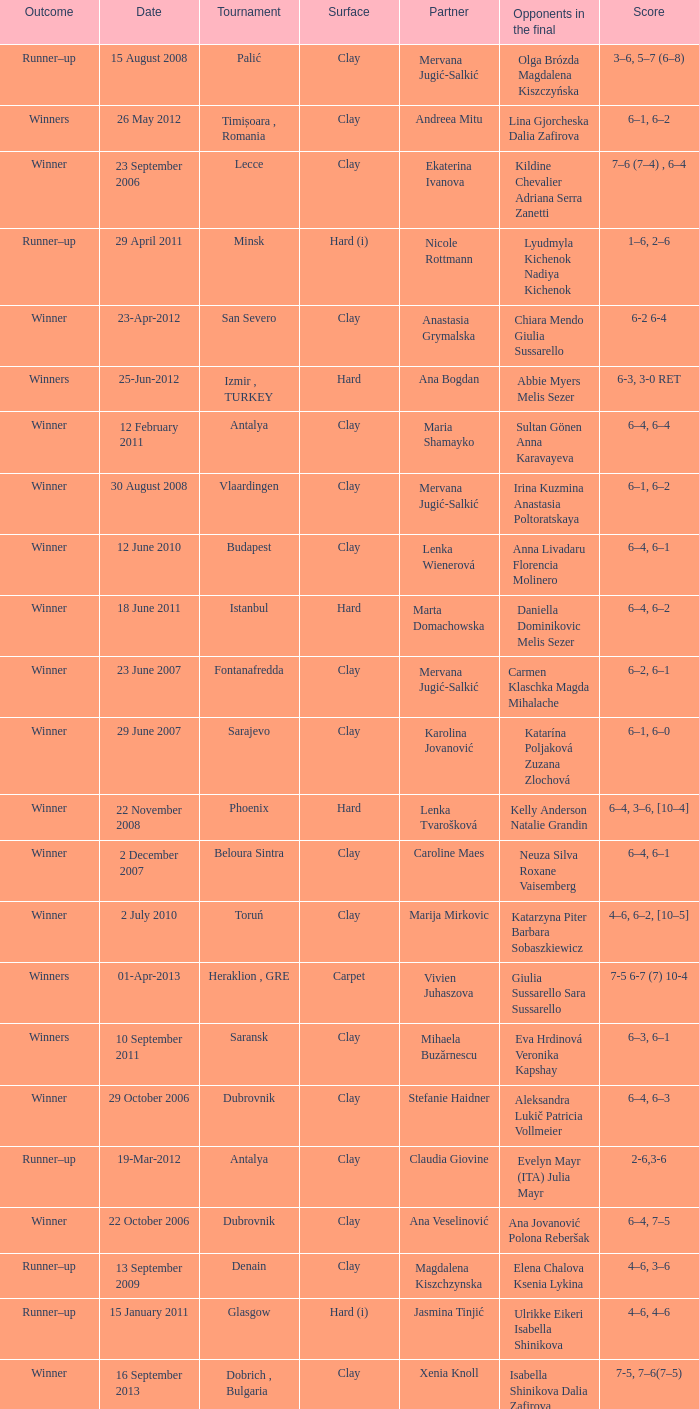Who were the opponents in the final at Noida? Kelly Anderson Chanelle Scheepers. 